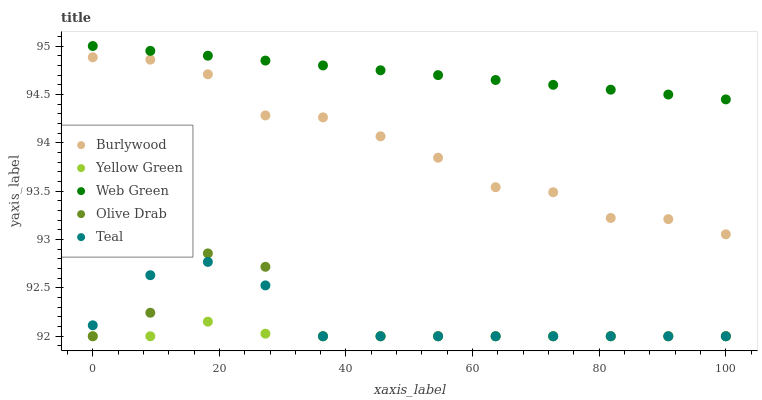Does Yellow Green have the minimum area under the curve?
Answer yes or no. Yes. Does Web Green have the maximum area under the curve?
Answer yes or no. Yes. Does Olive Drab have the minimum area under the curve?
Answer yes or no. No. Does Olive Drab have the maximum area under the curve?
Answer yes or no. No. Is Web Green the smoothest?
Answer yes or no. Yes. Is Olive Drab the roughest?
Answer yes or no. Yes. Is Teal the smoothest?
Answer yes or no. No. Is Teal the roughest?
Answer yes or no. No. Does Olive Drab have the lowest value?
Answer yes or no. Yes. Does Web Green have the lowest value?
Answer yes or no. No. Does Web Green have the highest value?
Answer yes or no. Yes. Does Olive Drab have the highest value?
Answer yes or no. No. Is Burlywood less than Web Green?
Answer yes or no. Yes. Is Burlywood greater than Olive Drab?
Answer yes or no. Yes. Does Teal intersect Yellow Green?
Answer yes or no. Yes. Is Teal less than Yellow Green?
Answer yes or no. No. Is Teal greater than Yellow Green?
Answer yes or no. No. Does Burlywood intersect Web Green?
Answer yes or no. No. 